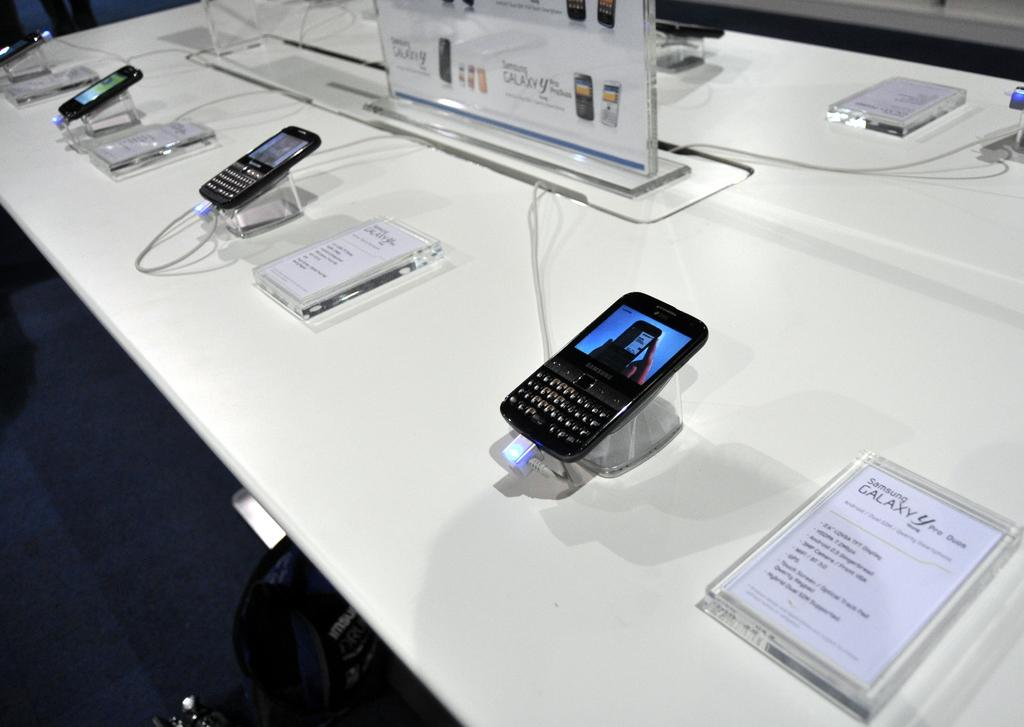Provide a one-sentence caption for the provided image. A row of Samsung Galaxy Phones are on display in a store. 